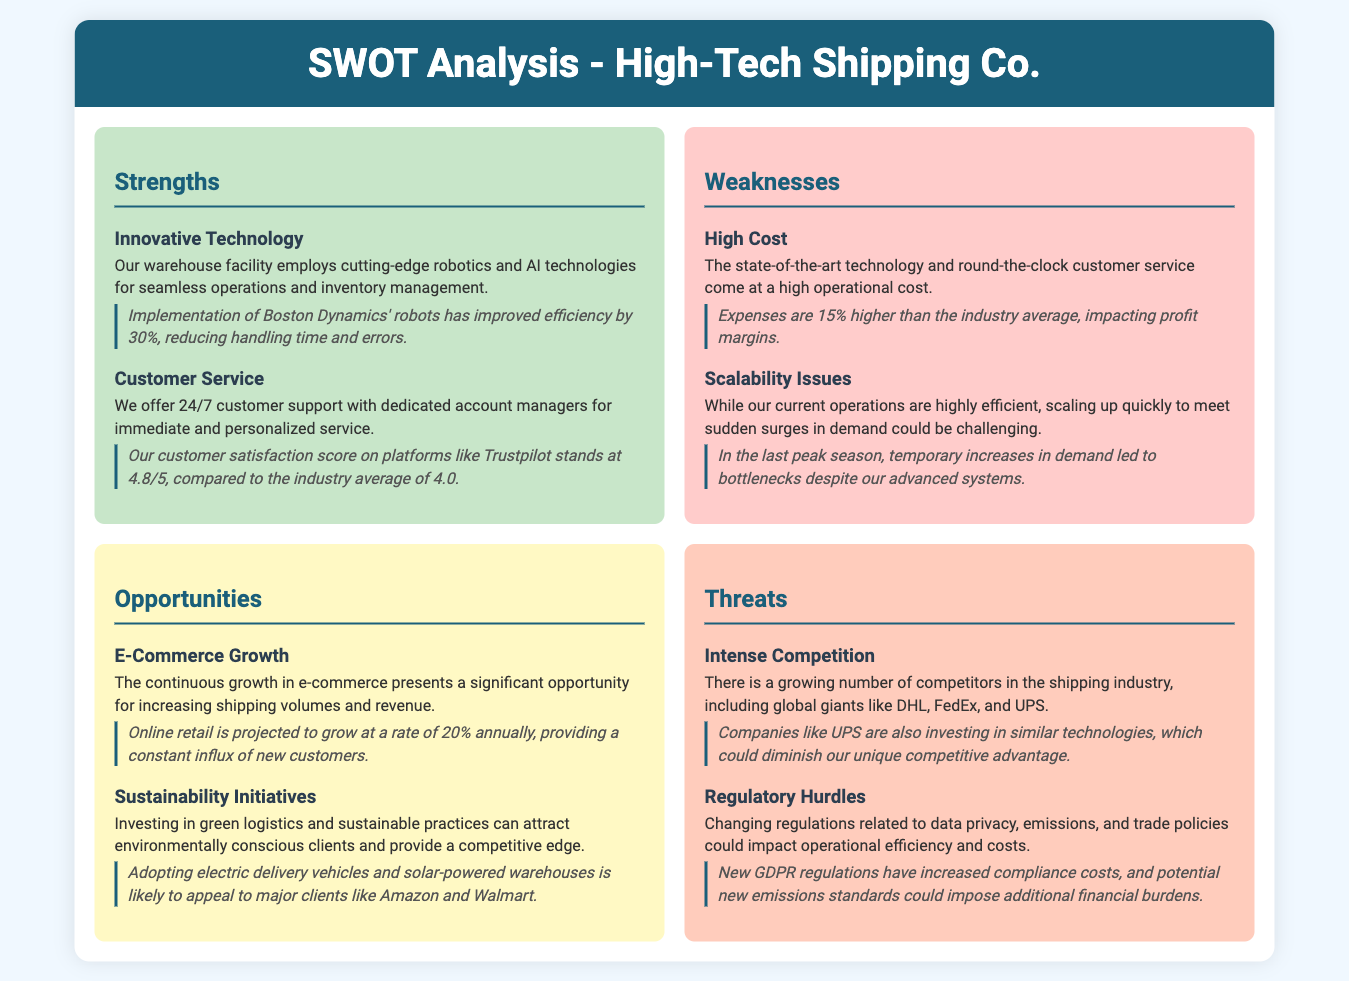What is the customer satisfaction score on Trustpilot? The document mentions the customer satisfaction score on Trustpilot as 4.8/5.
Answer: 4.8/5 What is one innovative technology used in the warehouse facility? The document examples cutting-edge robotics implemented from Boston Dynamics to improve efficiency.
Answer: Robotics What percentage higher are expenses compared to the industry average? The document states that expenses are 15% higher than the industry average.
Answer: 15% What is a potential opportunity for High-Tech Shipping Co.? The document discusses e-commerce growth as a significant opportunity for increasing volumes and revenue.
Answer: E-commerce growth What threat is highlighted due to competitors' actions? The document mentions that companies like UPS are investing in similar technologies, diminishing the competitive advantage.
Answer: Intense Competition What type of customer service is offered? The document details a 24/7 customer support with dedicated account managers.
Answer: 24/7 customer support What is a weakness related to scaling operations? The document indicates challenges in quickly scaling up to meet sudden surges in demand.
Answer: Scalability Issues What environmental initiative can attract clients? The document highlights investing in green logistics and adopting electric delivery vehicles as appealing to major clients.
Answer: Sustainability Initiatives 